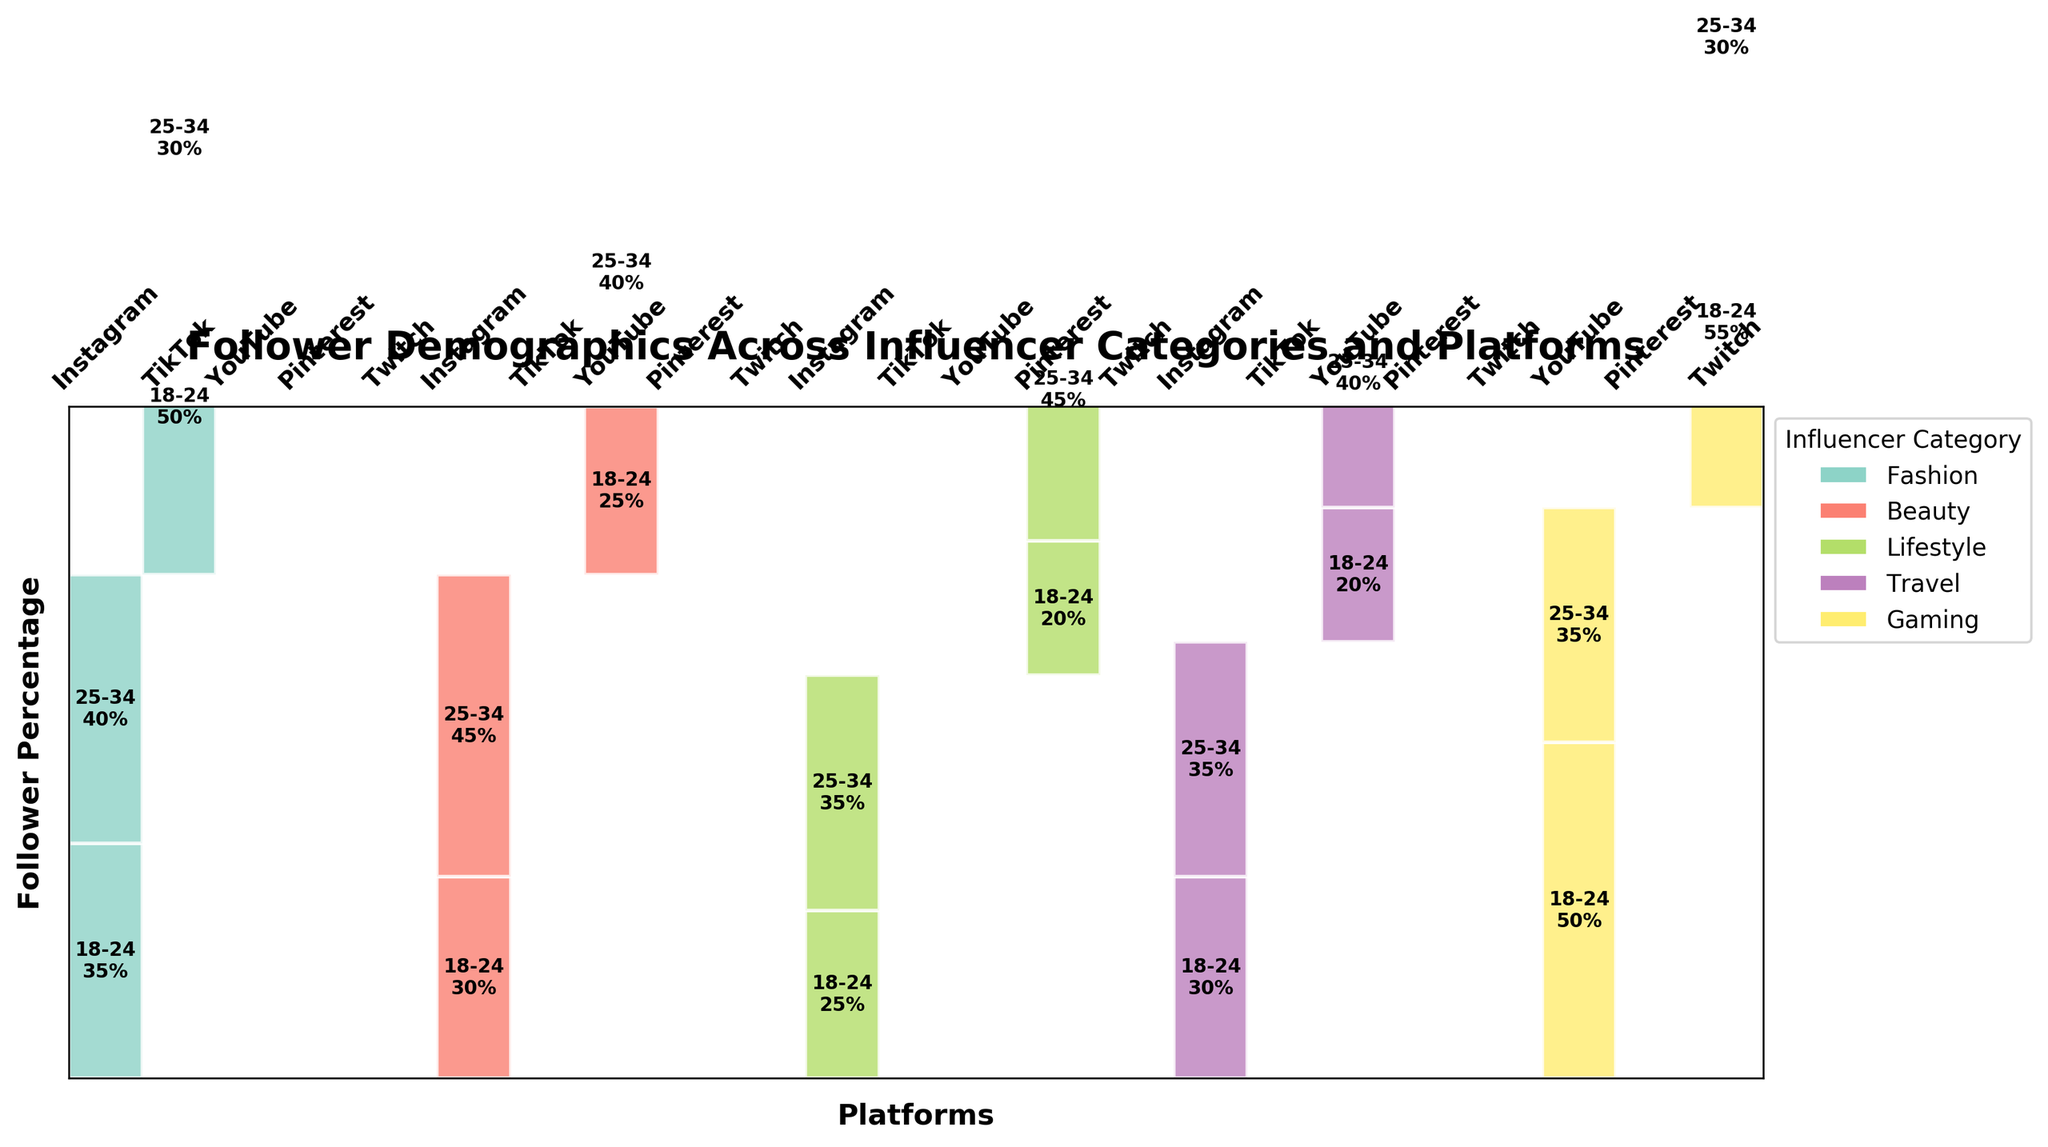What is the title of the plot? The title of the plot is displayed prominently at the top, which reads "Follower Demographics Across Influencer Categories and Platforms."
Answer: Follower Demographics Across Influencer Categories and Platforms Which influencer category has the highest percentage of followers aged 18-24 on TikTok? Looking at the category sections for TikTok, Fashion shows a larger rectangle for 18-24 compared to any other category.
Answer: Fashion How many unique platforms are represented in the plot? The plot includes sections for each unique platform, and by counting these sections, we can see that there are five platforms: Instagram, TikTok, YouTube, Pinterest, and Twitch.
Answer: 5 Which age group dominates the follower base for Gaming influencers on Twitch? In the Gaming section for Twitch, the age group 18-24 has a noticeably larger rectangle compared to 25-34, indicating a higher percentage
Answer: 18-24 Between Instagram and YouTube, which platform has a higher percentage of 25-34 followers for Travel influencers? Comparing the Travel sections for Instagram and YouTube, Instagram has a smaller segment labeled with 35% for the 25-34 age group, while YouTube has 40% labeled.
Answer: YouTube For Beauty influencers, which platform has the smallest percentage of followers aged 18-24? Looking at the sections for Beauty influencers, YouTube has the smallest segment for 18-24 labeled with 25%, while Instagram has a larger segment labeled with 30%.
Answer: YouTube Compare the percentage of 18-24 followers for Gaming influencers on Twitch and YouTube. Which platform has a higher percentage? Observing the rectangles for the Gaming category, Twitch has a larger segment labeled with 55% for the 18-24 age group compared to YouTube's 50%.
Answer: Twitch What percentage of Fashion followers on Instagram are aged 25-34? In the Fashion section for Instagram, the segment labeled 25-34 is marked with 40%.
Answer: 40% Which category and platform combination has the highest overall percentage of a single age group, and what is that percentage? Examining all the segments, Gaming on Twitch has the largest single segment labeled with 55% for the 18-24 age group.
Answer: Gaming on Twitch, 55% For Lifestyle influencers, which platform has a larger percentage of 25-34 followers, Instagram or Pinterest? Comparing segments for Lifestyle, Pinterest shows a segment labeled with 45% for the 25-34 age group, which is larger than Instagram's 35%.
Answer: Pinterest 